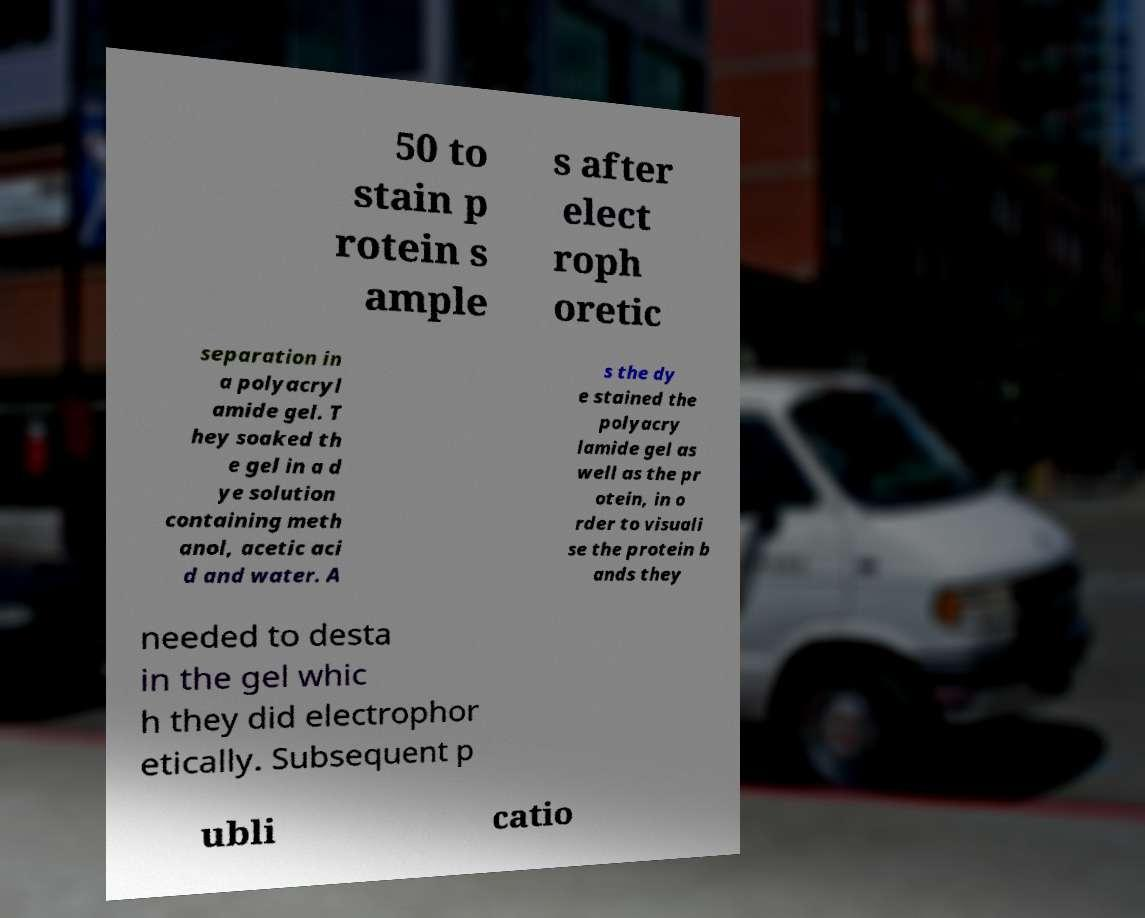Could you extract and type out the text from this image? 50 to stain p rotein s ample s after elect roph oretic separation in a polyacryl amide gel. T hey soaked th e gel in a d ye solution containing meth anol, acetic aci d and water. A s the dy e stained the polyacry lamide gel as well as the pr otein, in o rder to visuali se the protein b ands they needed to desta in the gel whic h they did electrophor etically. Subsequent p ubli catio 